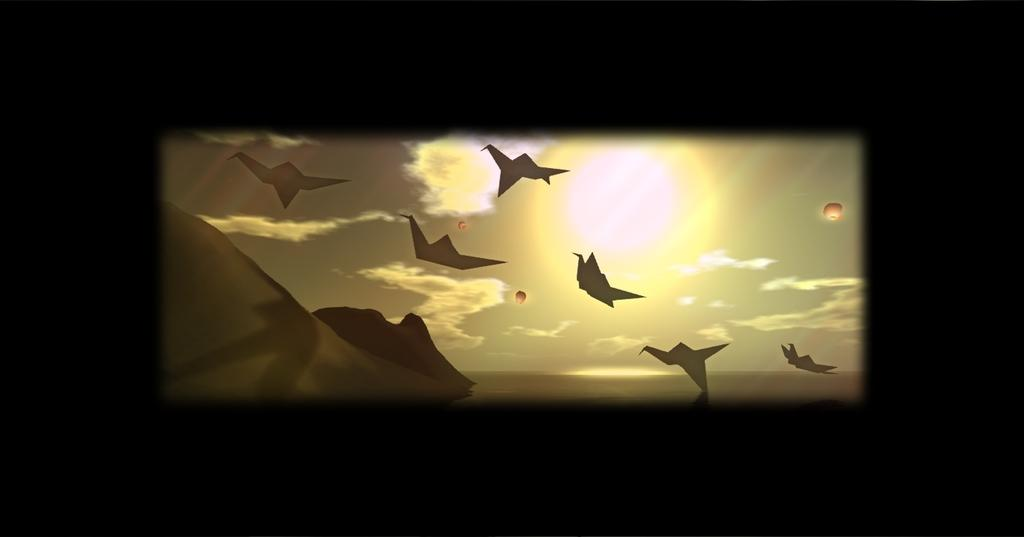What is happening in the sky in the image? There are objects flying in the sky, which are identified as sky lanterns. What is the source of light in the sky? The sun is visible in the image. What type of quill is being used to write in the sky by the sky lanterns? There is no quill present in the image, as the objects flying in the sky are sky lanterns, not birds or any other creatures that might use a quill. 